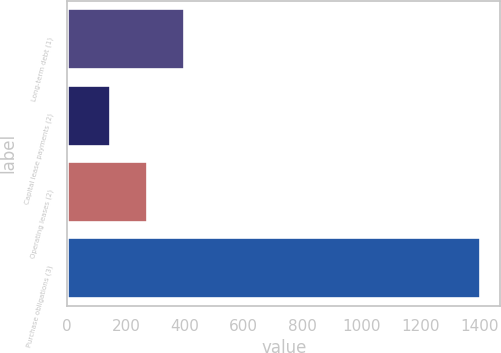<chart> <loc_0><loc_0><loc_500><loc_500><bar_chart><fcel>Long-term debt (1)<fcel>Capital lease payments (2)<fcel>Operating leases (2)<fcel>Purchase obligations (3)<nl><fcel>397.2<fcel>146<fcel>271.6<fcel>1402<nl></chart> 